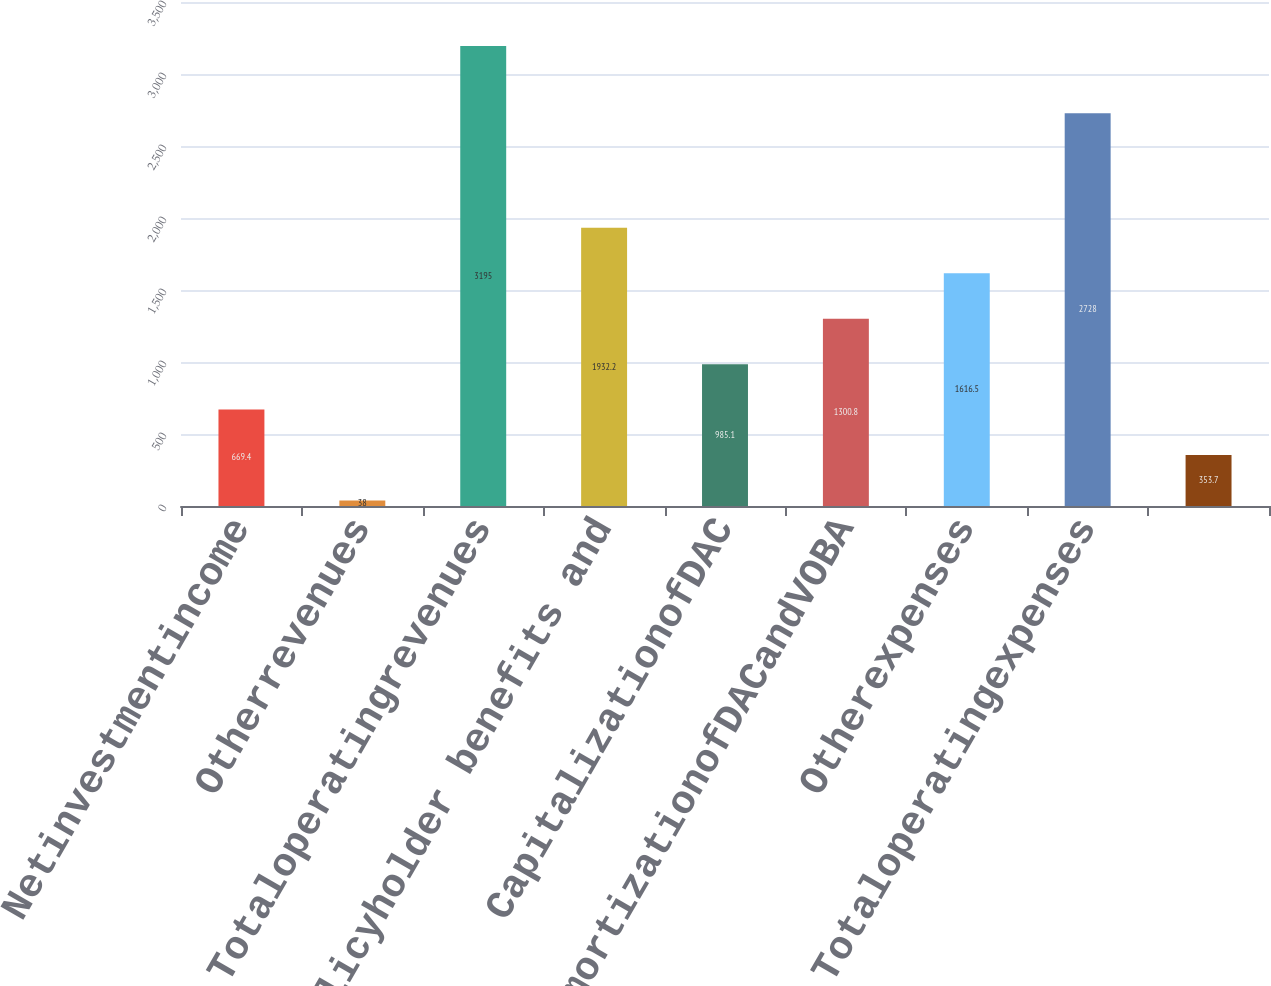<chart> <loc_0><loc_0><loc_500><loc_500><bar_chart><fcel>Netinvestmentincome<fcel>Otherrevenues<fcel>Totaloperatingrevenues<fcel>Policyholder benefits and<fcel>CapitalizationofDAC<fcel>AmortizationofDACandVOBA<fcel>Otherexpenses<fcel>Totaloperatingexpenses<fcel>Unnamed: 8<nl><fcel>669.4<fcel>38<fcel>3195<fcel>1932.2<fcel>985.1<fcel>1300.8<fcel>1616.5<fcel>2728<fcel>353.7<nl></chart> 